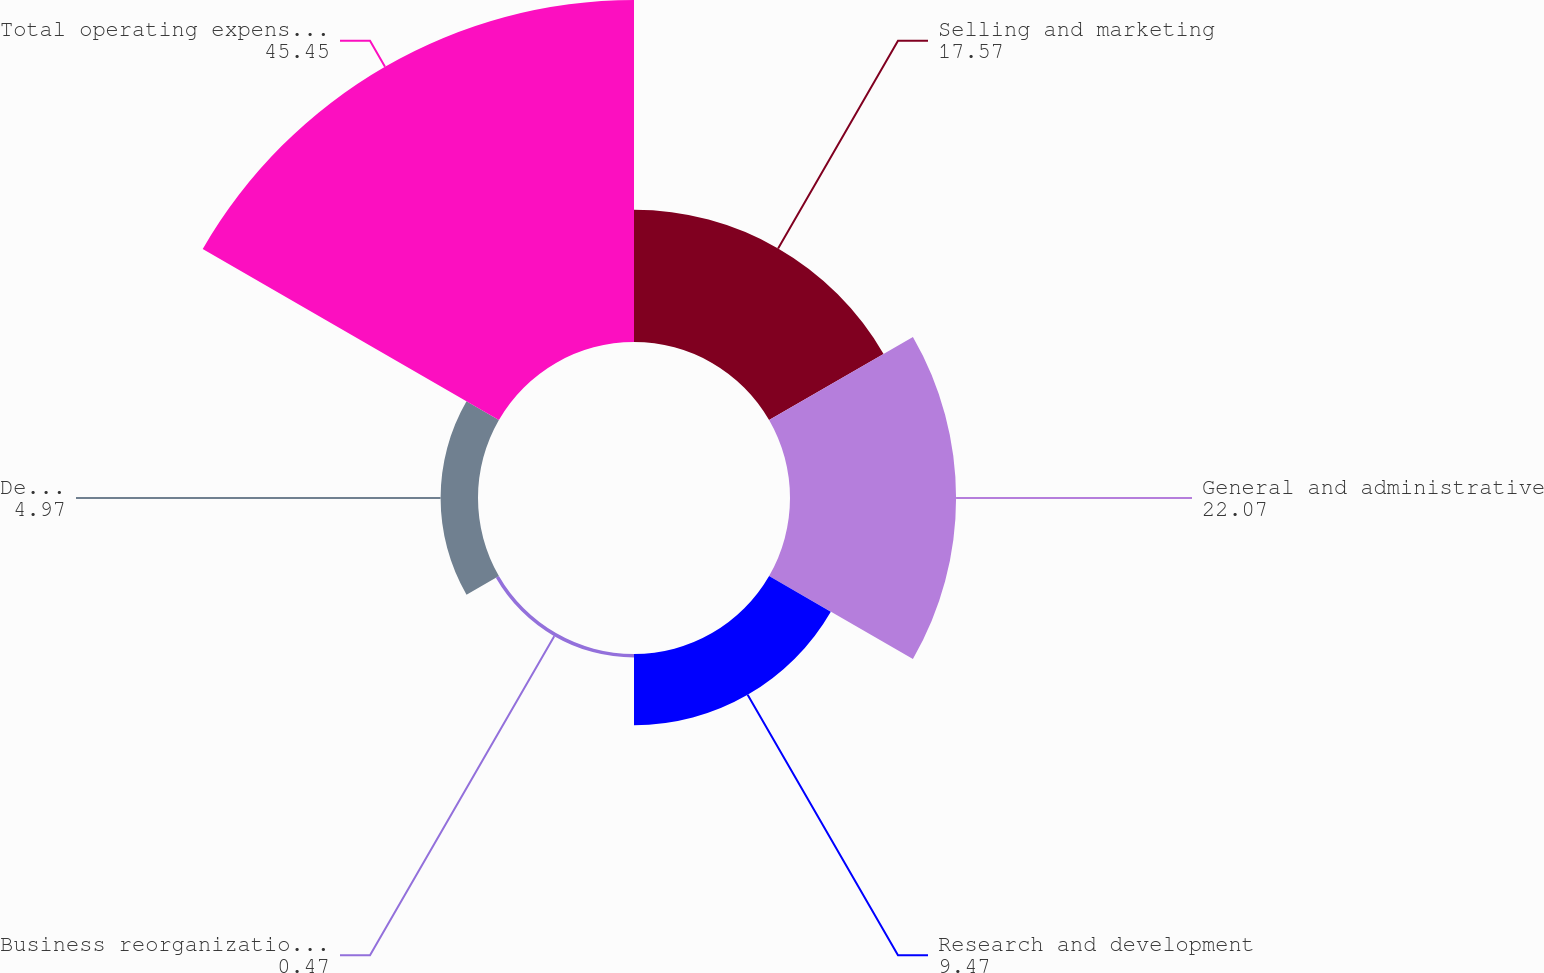Convert chart to OTSL. <chart><loc_0><loc_0><loc_500><loc_500><pie_chart><fcel>Selling and marketing<fcel>General and administrative<fcel>Research and development<fcel>Business reorganization and<fcel>Depreciation and amortization<fcel>Total operating expenses (1)<nl><fcel>17.57%<fcel>22.07%<fcel>9.47%<fcel>0.47%<fcel>4.97%<fcel>45.45%<nl></chart> 